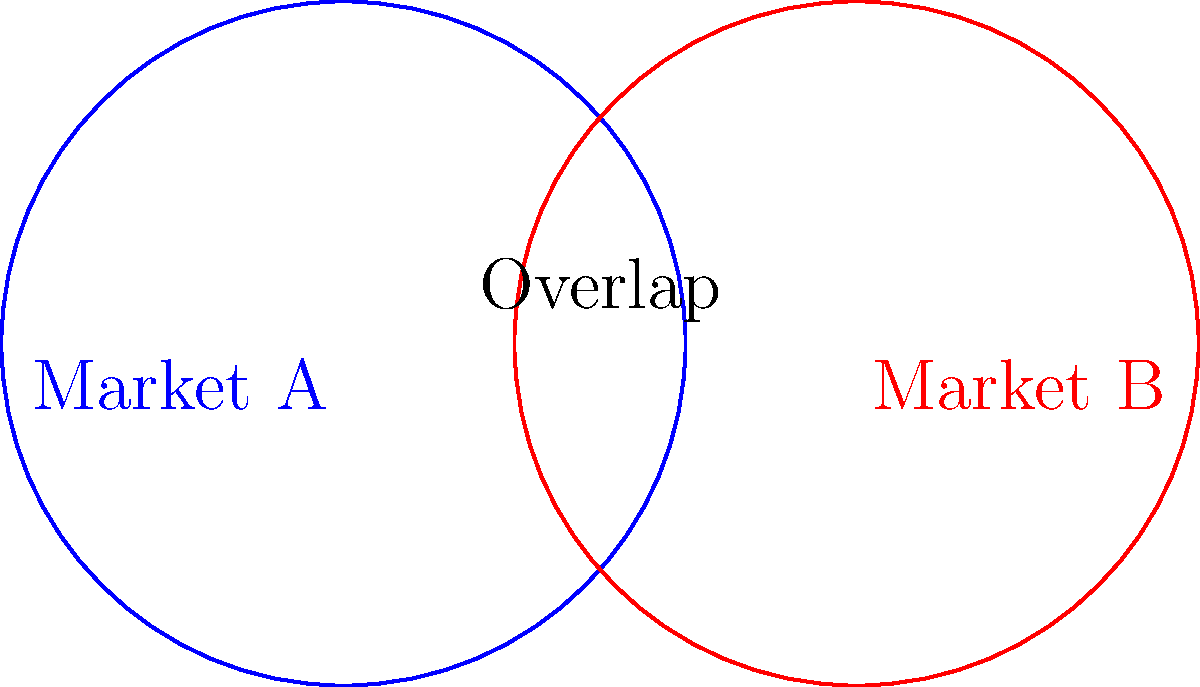Two competing financial products have circular market shares with equal radii of 1 unit. Their centers are 1.5 units apart. Calculate the area of the overlapping region, representing the shared market, to two decimal places. How might this overlap affect each product's strategy? To solve this problem, we'll use the formula for the area of the lens-shaped region formed by two overlapping circles. Let's break it down step-by-step:

1) The formula for the area of the overlapping region is:

   $$A = 2r^2 \arccos(\frac{d}{2r}) - d\sqrt{r^2 - (\frac{d}{2})^2}$$

   where $r$ is the radius of each circle and $d$ is the distance between their centers.

2) We're given:
   $r = 1$ unit
   $d = 1.5$ units

3) Let's substitute these values into the formula:

   $$A = 2(1^2) \arccos(\frac{1.5}{2(1)}) - 1.5\sqrt{1^2 - (\frac{1.5}{2})^2}$$

4) Simplify:
   $$A = 2 \arccos(0.75) - 1.5\sqrt{1 - 0.5625}$$

5) Calculate:
   $$A = 2(0.7227) - 1.5(0.6614)$$
   $$A = 1.4454 - 0.9921$$
   $$A = 0.4533$$

6) Rounding to two decimal places:
   $$A \approx 0.45$$ square units

This overlap suggests that the two products are competing for a significant portion of the same market. Strategies might include:
1) Differentiating their products to appeal to unique segments within the overlap.
2) Focusing marketing efforts on the non-overlapping areas to solidify their unique market share.
3) Considering a partnership or merger to dominate the overlapping market segment.
Answer: 0.45 square units 